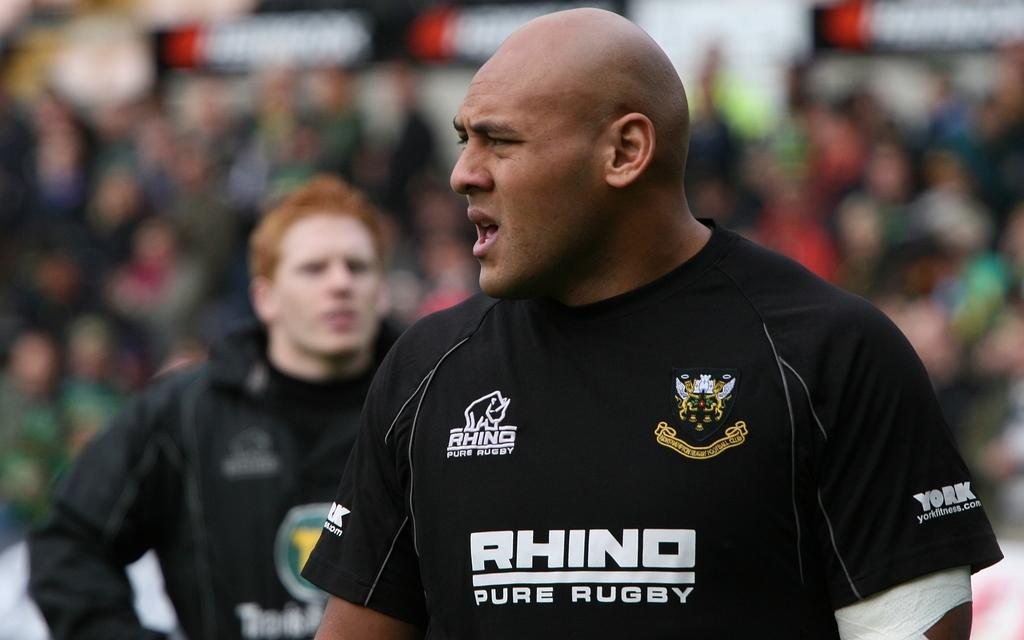How many men are present in the image? There are two men standing in the image. What is the position of one of the men? One man is looking to the left. What might the man be doing based on his appearance? The man appears to be speaking. What can be seen in the background of the image? There is a crowd of people in the background of the image. How would you describe the appearance of the crowd? The crowd is blurred. What type of bag is the man holding in the image? There is no bag visible in the image; the man appears to be speaking and looking to the left. 